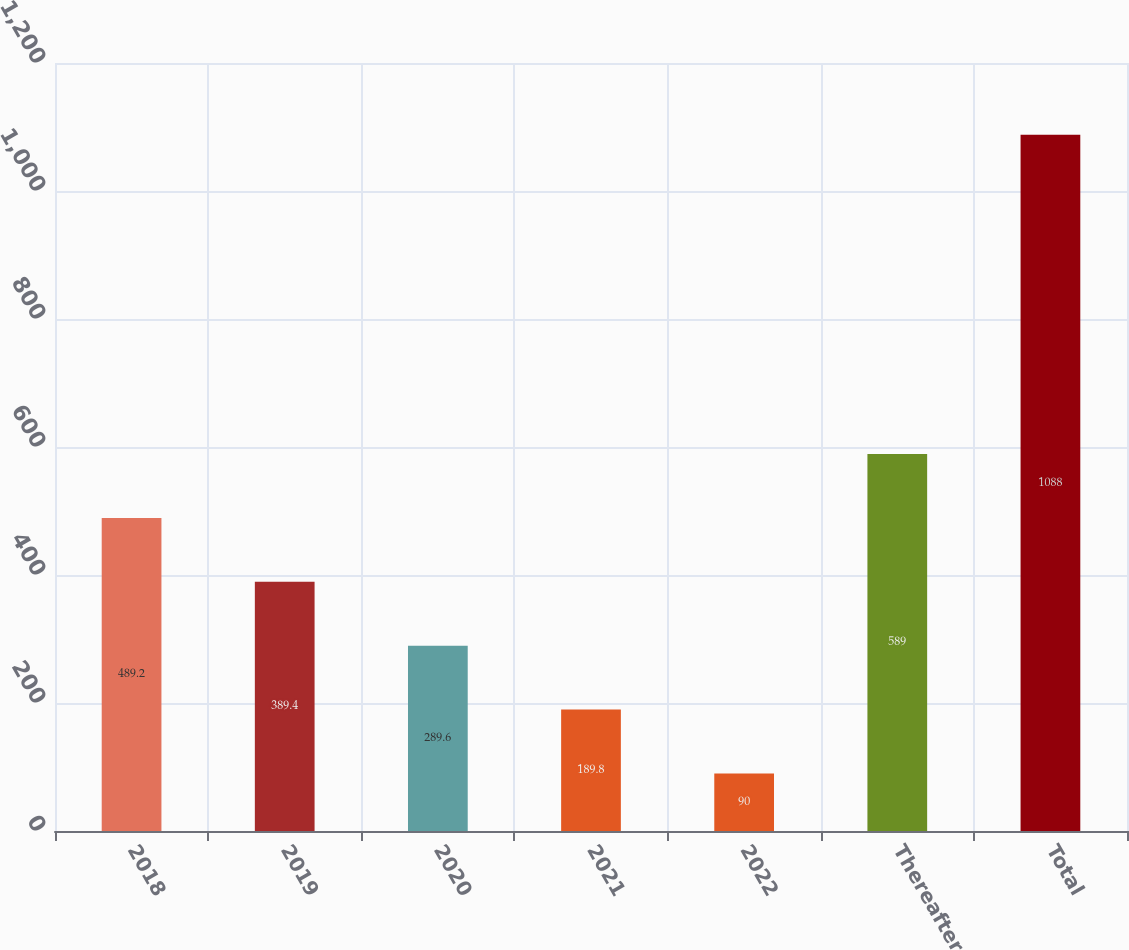<chart> <loc_0><loc_0><loc_500><loc_500><bar_chart><fcel>2018<fcel>2019<fcel>2020<fcel>2021<fcel>2022<fcel>Thereafter<fcel>Total<nl><fcel>489.2<fcel>389.4<fcel>289.6<fcel>189.8<fcel>90<fcel>589<fcel>1088<nl></chart> 